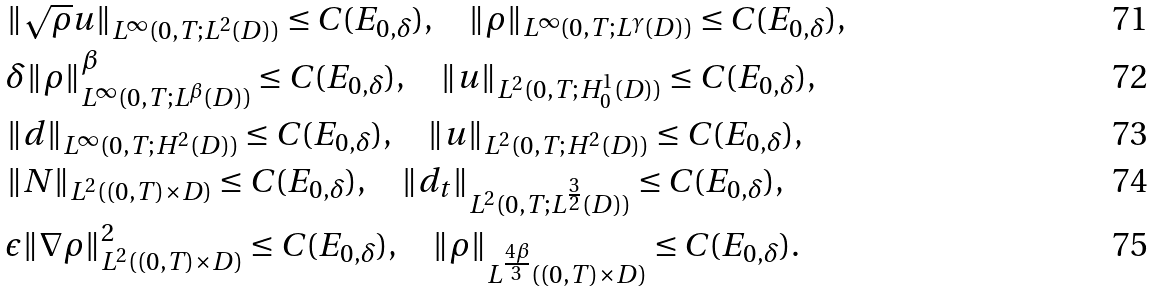Convert formula to latex. <formula><loc_0><loc_0><loc_500><loc_500>& \| \sqrt { \rho } u \| _ { L ^ { \infty } ( 0 , T ; L ^ { 2 } ( D ) ) } \leq C ( E _ { 0 , \delta } ) , \quad \| \rho \| _ { L ^ { \infty } ( 0 , T ; L ^ { \gamma } ( D ) ) } \leq C ( E _ { 0 , \delta } ) , \\ & \delta \| \rho \| ^ { \beta } _ { L ^ { \infty } ( 0 , T ; L ^ { \beta } ( D ) ) } \leq C ( E _ { 0 , \delta } ) , \quad \| u \| _ { L ^ { 2 } ( 0 , T ; H ^ { 1 } _ { 0 } ( D ) ) } \leq C ( E _ { 0 , \delta } ) , \\ & \| d \| _ { L ^ { \infty } ( 0 , T ; H ^ { 2 } ( D ) ) } \leq C ( E _ { 0 , \delta } ) , \quad \| u \| _ { L ^ { 2 } ( 0 , T ; H ^ { 2 } ( D ) ) } \leq C ( E _ { 0 , \delta } ) , \\ & \| N \| _ { L ^ { 2 } ( ( 0 , T ) \times D ) } \leq C ( E _ { 0 , \delta } ) , \quad \| d _ { t } \| _ { L ^ { 2 } ( 0 , T ; L ^ { \frac { 3 } { 2 } } ( D ) ) } \leq C ( E _ { 0 , \delta } ) , \\ & \epsilon \| \nabla \rho \| ^ { 2 } _ { L ^ { 2 } ( ( 0 , T ) \times D ) } \leq C ( E _ { 0 , \delta } ) , \quad \| \rho \| _ { L ^ { \frac { 4 \beta } { 3 } } ( ( 0 , T ) \times D ) } \leq C ( E _ { 0 , \delta } ) .</formula> 